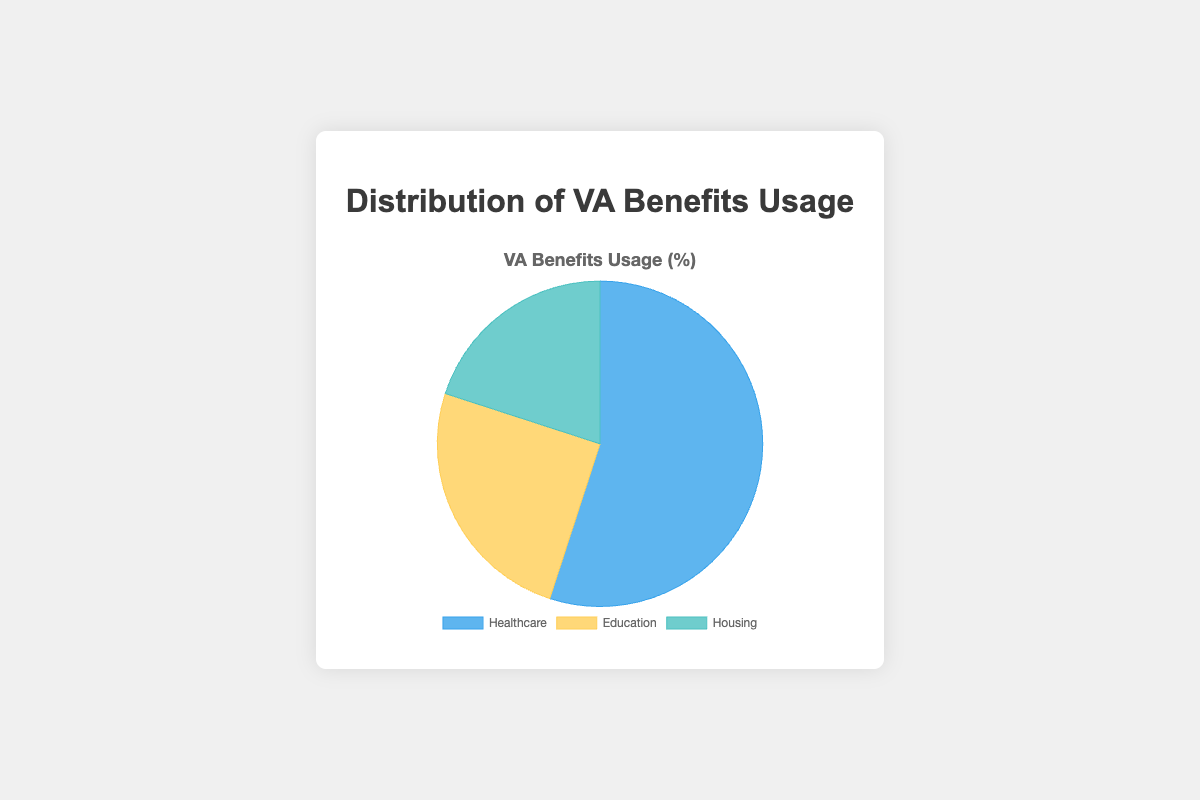Which category has the highest percentage of VA benefits usage? By looking at the pie chart, the sector with the largest share will represent the highest percentage. The "Healthcare" category has the biggest portion of the pie.
Answer: Healthcare What is the difference in percentage between the Healthcare and Education categories? The Healthcare category has a percentage of 55%, and the Education category has 25%. The difference is calculated as 55% - 25% = 30%.
Answer: 30% Which category uses VA benefits more, Housing or Education? By comparing the two values, Housing is 20% and Education is 25%. Education has a higher percentage.
Answer: Education What is the sum of the percentages for Education and Housing? The percentage for Education is 25% and for Housing is 20%. The sum is 25% + 20% = 45%.
Answer: 45% What is the percentage of VA benefits not used for Healthcare? The total percentage for all categories must be 100%. If Healthcare uses 55%, then the percentage not used for Healthcare is 100% - 55% = 45%.
Answer: 45% Is the combination of Healthcare and Housing usage percentage greater than Education? The percentage for Healthcare is 55% and for Housing is 20%. Their combined percentage is 55% + 20% = 75%, which is greater than Education's 25%.
Answer: Yes What color represents the Housing category in the pie chart? Looking at the pie chart, the Housing section is colored in a specific shade. According to the color description provided, it should be turquoise or light blue.
Answer: Turquoise How many categories have a usage percentage below 30%? By examining the pie chart, the Education (25%) and Housing (20%) categories are both below 30%. Therefore, there are 2 categories below 30%.
Answer: 2 What is the visual attribute of the category with the second highest benefits usage? The second highest benefits usage is the Education category, which is represented in the pie chart by a specific color and size proportion. It is colored yellow and has the second-largest sector in the chart.
Answer: Yellow If the percentage for Housing is increased by 10%, how much would the total percentage for all categories exceed 100% by? If Housing is increased by 10%, its new percentage would be 20% + 10% = 30%. The total would then be 55% (Healthcare) + 25% (Education) + 30% (Housing) = 110%. The total exceeds 100% by 110% - 100% = 10%.
Answer: 10% 